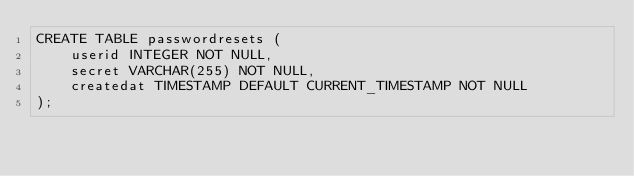Convert code to text. <code><loc_0><loc_0><loc_500><loc_500><_SQL_>CREATE TABLE passwordresets (
	userid INTEGER NOT NULL,
	secret VARCHAR(255) NOT NULL,
	createdat TIMESTAMP DEFAULT CURRENT_TIMESTAMP NOT NULL
);
</code> 